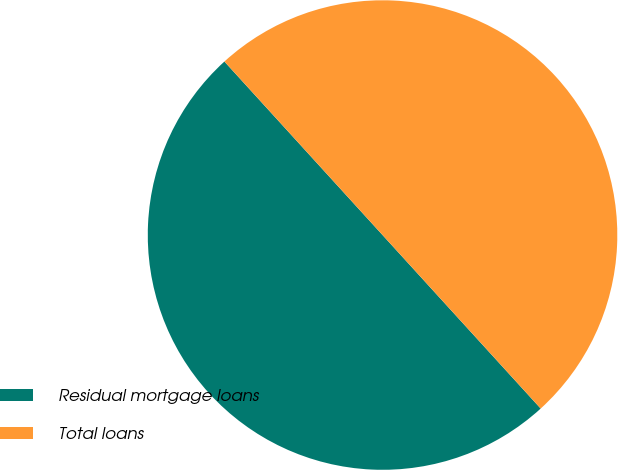Convert chart. <chart><loc_0><loc_0><loc_500><loc_500><pie_chart><fcel>Residual mortgage loans<fcel>Total loans<nl><fcel>50.0%<fcel>50.0%<nl></chart> 